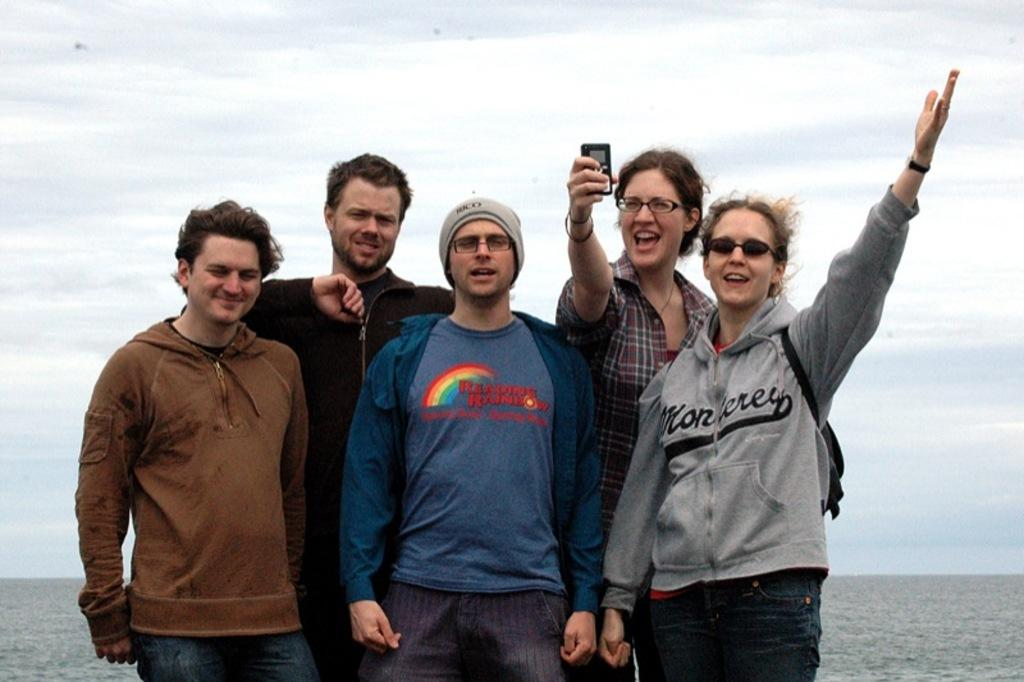Who or what is present in the image? There are people in the image. What natural element can be seen in the image? There is water visible in the image. What is visible in the background of the image? The sky is visible in the background of the image. What type of horn can be heard in the image? There is no horn present in the image, and therefore no sound can be heard. 